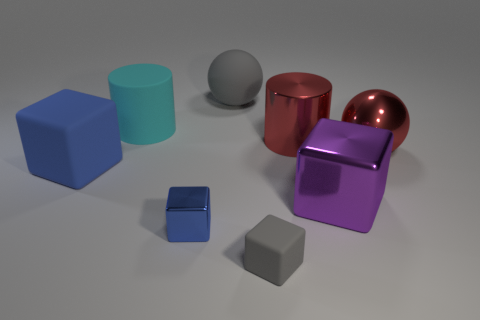Is there any sense of movement or static nature in this scene? The scene is very much static with no signs of movement. The objects are placed still on the surface, and their crisp shadows reinforce the idea that they are stationary. There's no blurring or distortion that might indicate motion. This static nature allows us to clearly observe the shapes, colors, and textures of each object. 